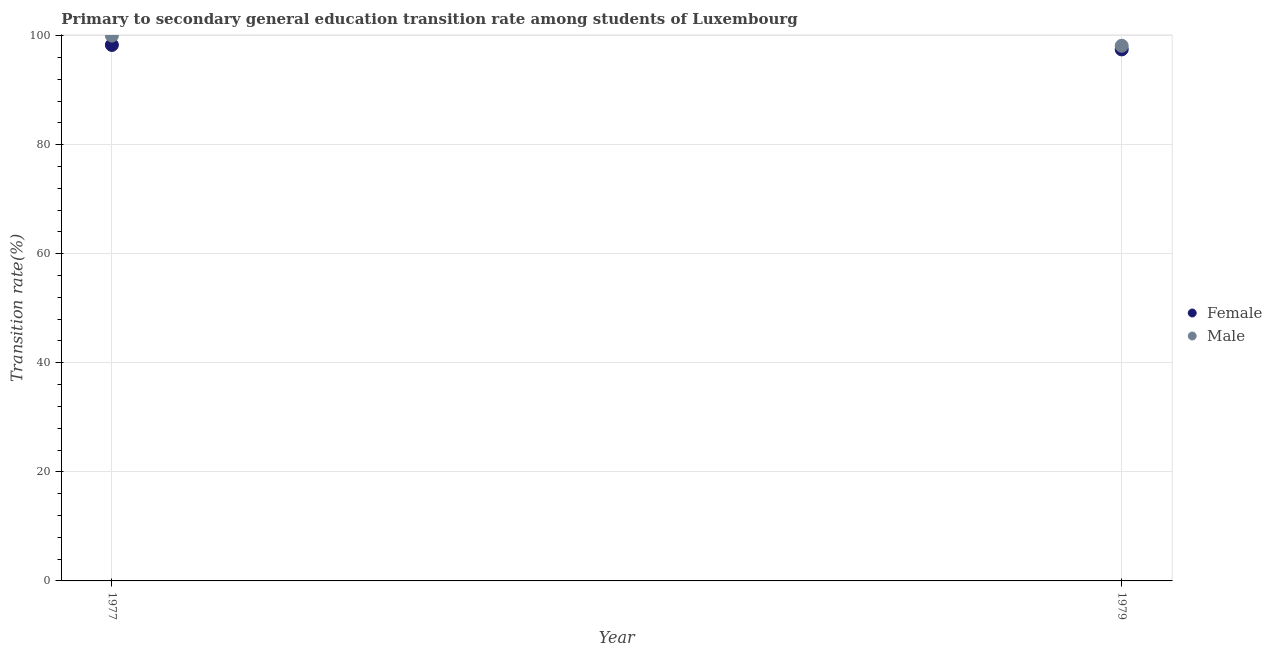How many different coloured dotlines are there?
Ensure brevity in your answer.  2. Is the number of dotlines equal to the number of legend labels?
Ensure brevity in your answer.  Yes. Across all years, what is the maximum transition rate among female students?
Provide a short and direct response. 98.28. Across all years, what is the minimum transition rate among female students?
Give a very brief answer. 97.46. In which year was the transition rate among female students maximum?
Provide a short and direct response. 1977. In which year was the transition rate among male students minimum?
Keep it short and to the point. 1979. What is the total transition rate among female students in the graph?
Keep it short and to the point. 195.74. What is the difference between the transition rate among male students in 1977 and that in 1979?
Your answer should be very brief. 1.87. What is the difference between the transition rate among male students in 1979 and the transition rate among female students in 1977?
Your answer should be compact. -0.15. What is the average transition rate among female students per year?
Your response must be concise. 97.87. In the year 1977, what is the difference between the transition rate among female students and transition rate among male students?
Keep it short and to the point. -1.72. In how many years, is the transition rate among female students greater than 96 %?
Provide a succinct answer. 2. What is the ratio of the transition rate among male students in 1977 to that in 1979?
Your answer should be very brief. 1.02. Is the transition rate among male students in 1977 less than that in 1979?
Give a very brief answer. No. In how many years, is the transition rate among male students greater than the average transition rate among male students taken over all years?
Offer a terse response. 1. Is the transition rate among male students strictly greater than the transition rate among female students over the years?
Give a very brief answer. Yes. How many years are there in the graph?
Give a very brief answer. 2. Does the graph contain any zero values?
Make the answer very short. No. What is the title of the graph?
Keep it short and to the point. Primary to secondary general education transition rate among students of Luxembourg. Does "Under five" appear as one of the legend labels in the graph?
Your answer should be compact. No. What is the label or title of the X-axis?
Offer a very short reply. Year. What is the label or title of the Y-axis?
Your response must be concise. Transition rate(%). What is the Transition rate(%) in Female in 1977?
Keep it short and to the point. 98.28. What is the Transition rate(%) of Female in 1979?
Ensure brevity in your answer.  97.46. What is the Transition rate(%) in Male in 1979?
Offer a very short reply. 98.13. Across all years, what is the maximum Transition rate(%) in Female?
Ensure brevity in your answer.  98.28. Across all years, what is the minimum Transition rate(%) in Female?
Your answer should be very brief. 97.46. Across all years, what is the minimum Transition rate(%) in Male?
Ensure brevity in your answer.  98.13. What is the total Transition rate(%) in Female in the graph?
Your answer should be compact. 195.74. What is the total Transition rate(%) in Male in the graph?
Your answer should be compact. 198.13. What is the difference between the Transition rate(%) in Female in 1977 and that in 1979?
Offer a very short reply. 0.81. What is the difference between the Transition rate(%) of Male in 1977 and that in 1979?
Provide a succinct answer. 1.87. What is the difference between the Transition rate(%) in Female in 1977 and the Transition rate(%) in Male in 1979?
Make the answer very short. 0.15. What is the average Transition rate(%) of Female per year?
Make the answer very short. 97.87. What is the average Transition rate(%) of Male per year?
Give a very brief answer. 99.07. In the year 1977, what is the difference between the Transition rate(%) in Female and Transition rate(%) in Male?
Provide a succinct answer. -1.72. In the year 1979, what is the difference between the Transition rate(%) in Female and Transition rate(%) in Male?
Offer a terse response. -0.67. What is the ratio of the Transition rate(%) of Female in 1977 to that in 1979?
Give a very brief answer. 1.01. What is the ratio of the Transition rate(%) of Male in 1977 to that in 1979?
Your response must be concise. 1.02. What is the difference between the highest and the second highest Transition rate(%) in Female?
Give a very brief answer. 0.81. What is the difference between the highest and the second highest Transition rate(%) of Male?
Ensure brevity in your answer.  1.87. What is the difference between the highest and the lowest Transition rate(%) in Female?
Offer a very short reply. 0.81. What is the difference between the highest and the lowest Transition rate(%) of Male?
Give a very brief answer. 1.87. 